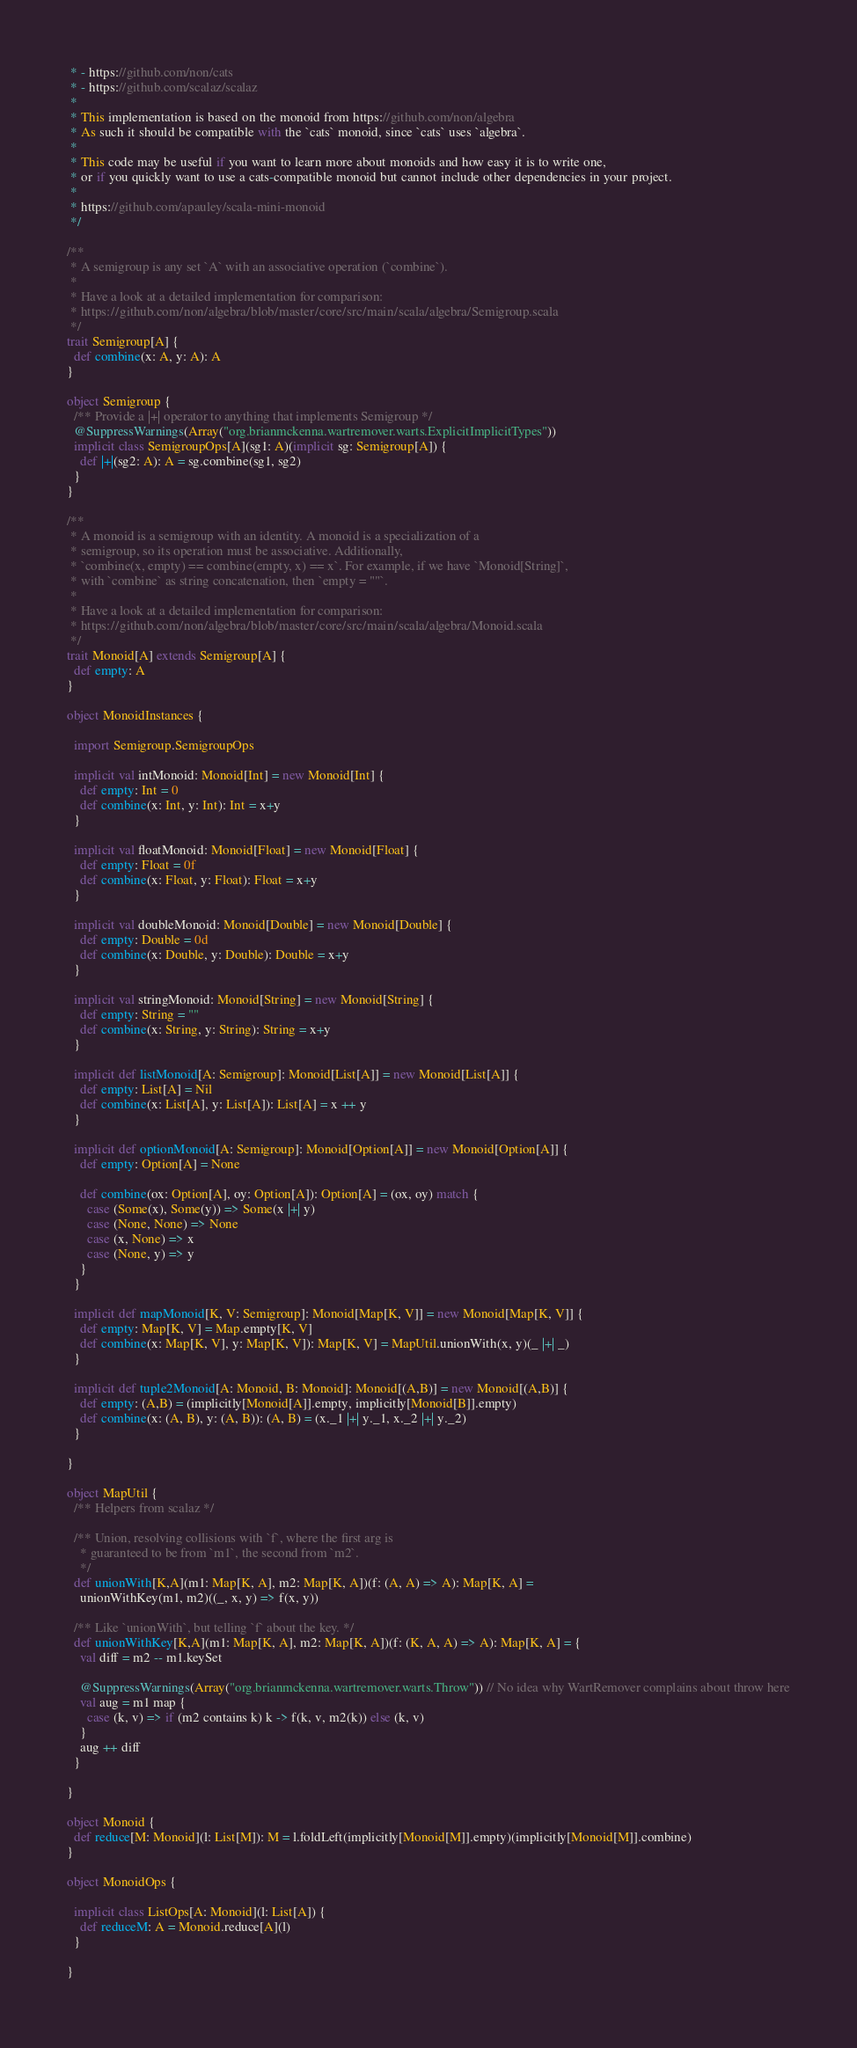<code> <loc_0><loc_0><loc_500><loc_500><_Scala_> * - https://github.com/non/cats
 * - https://github.com/scalaz/scalaz
 *
 * This implementation is based on the monoid from https://github.com/non/algebra
 * As such it should be compatible with the `cats` monoid, since `cats` uses `algebra`.
 *
 * This code may be useful if you want to learn more about monoids and how easy it is to write one,
 * or if you quickly want to use a cats-compatible monoid but cannot include other dependencies in your project.
 *
 * https://github.com/apauley/scala-mini-monoid
 */

/**
 * A semigroup is any set `A` with an associative operation (`combine`).
 *
 * Have a look at a detailed implementation for comparison:
 * https://github.com/non/algebra/blob/master/core/src/main/scala/algebra/Semigroup.scala
 */
trait Semigroup[A] {
  def combine(x: A, y: A): A
}

object Semigroup {
  /** Provide a |+| operator to anything that implements Semigroup */
  @SuppressWarnings(Array("org.brianmckenna.wartremover.warts.ExplicitImplicitTypes"))
  implicit class SemigroupOps[A](sg1: A)(implicit sg: Semigroup[A]) {
    def |+|(sg2: A): A = sg.combine(sg1, sg2)
  }
}

/**
 * A monoid is a semigroup with an identity. A monoid is a specialization of a
 * semigroup, so its operation must be associative. Additionally,
 * `combine(x, empty) == combine(empty, x) == x`. For example, if we have `Monoid[String]`,
 * with `combine` as string concatenation, then `empty = ""`.
 *
 * Have a look at a detailed implementation for comparison:
 * https://github.com/non/algebra/blob/master/core/src/main/scala/algebra/Monoid.scala
 */
trait Monoid[A] extends Semigroup[A] {
  def empty: A
}

object MonoidInstances {

  import Semigroup.SemigroupOps

  implicit val intMonoid: Monoid[Int] = new Monoid[Int] {
    def empty: Int = 0
    def combine(x: Int, y: Int): Int = x+y
  }

  implicit val floatMonoid: Monoid[Float] = new Monoid[Float] {
    def empty: Float = 0f
    def combine(x: Float, y: Float): Float = x+y
  }

  implicit val doubleMonoid: Monoid[Double] = new Monoid[Double] {
    def empty: Double = 0d
    def combine(x: Double, y: Double): Double = x+y
  }

  implicit val stringMonoid: Monoid[String] = new Monoid[String] {
    def empty: String = ""
    def combine(x: String, y: String): String = x+y
  }

  implicit def listMonoid[A: Semigroup]: Monoid[List[A]] = new Monoid[List[A]] {
    def empty: List[A] = Nil
    def combine(x: List[A], y: List[A]): List[A] = x ++ y
  }

  implicit def optionMonoid[A: Semigroup]: Monoid[Option[A]] = new Monoid[Option[A]] {
    def empty: Option[A] = None

    def combine(ox: Option[A], oy: Option[A]): Option[A] = (ox, oy) match {
      case (Some(x), Some(y)) => Some(x |+| y)
      case (None, None) => None
      case (x, None) => x
      case (None, y) => y
    }
  }

  implicit def mapMonoid[K, V: Semigroup]: Monoid[Map[K, V]] = new Monoid[Map[K, V]] {
    def empty: Map[K, V] = Map.empty[K, V]
    def combine(x: Map[K, V], y: Map[K, V]): Map[K, V] = MapUtil.unionWith(x, y)(_ |+| _)
  }

  implicit def tuple2Monoid[A: Monoid, B: Monoid]: Monoid[(A,B)] = new Monoid[(A,B)] {
    def empty: (A,B) = (implicitly[Monoid[A]].empty, implicitly[Monoid[B]].empty)
    def combine(x: (A, B), y: (A, B)): (A, B) = (x._1 |+| y._1, x._2 |+| y._2)
  }

}

object MapUtil {
  /** Helpers from scalaz */

  /** Union, resolving collisions with `f`, where the first arg is
    * guaranteed to be from `m1`, the second from `m2`.
    */
  def unionWith[K,A](m1: Map[K, A], m2: Map[K, A])(f: (A, A) => A): Map[K, A] =
    unionWithKey(m1, m2)((_, x, y) => f(x, y))

  /** Like `unionWith`, but telling `f` about the key. */
  def unionWithKey[K,A](m1: Map[K, A], m2: Map[K, A])(f: (K, A, A) => A): Map[K, A] = {
    val diff = m2 -- m1.keySet

    @SuppressWarnings(Array("org.brianmckenna.wartremover.warts.Throw")) // No idea why WartRemover complains about throw here
    val aug = m1 map {
      case (k, v) => if (m2 contains k) k -> f(k, v, m2(k)) else (k, v)
    }
    aug ++ diff
  }

}

object Monoid {
  def reduce[M: Monoid](l: List[M]): M = l.foldLeft(implicitly[Monoid[M]].empty)(implicitly[Monoid[M]].combine)
}

object MonoidOps {

  implicit class ListOps[A: Monoid](l: List[A]) {
    def reduceM: A = Monoid.reduce[A](l)
  }

}
</code> 